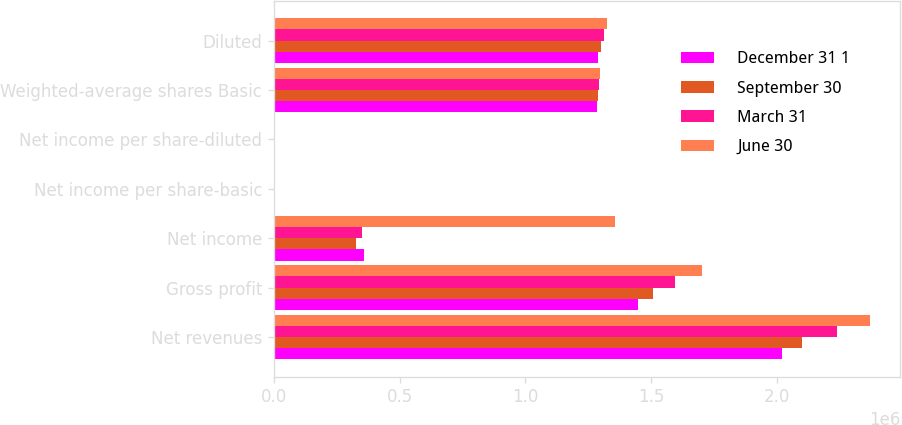Convert chart. <chart><loc_0><loc_0><loc_500><loc_500><stacked_bar_chart><ecel><fcel>Net revenues<fcel>Gross profit<fcel>Net income<fcel>Net income per share-basic<fcel>Net income per share-diluted<fcel>Weighted-average shares Basic<fcel>Diluted<nl><fcel>December 31 1<fcel>2.02059e+06<fcel>1.4472e+06<fcel>357113<fcel>0.28<fcel>0.28<fcel>1.28381e+06<fcel>1.28781e+06<nl><fcel>September 30<fcel>2.09799e+06<fcel>1.50622e+06<fcel>327342<fcel>0.25<fcel>0.25<fcel>1.28882e+06<fcel>1.30043e+06<nl><fcel>March 31<fcel>2.23785e+06<fcel>1.59394e+06<fcel>349736<fcel>0.27<fcel>0.27<fcel>1.29351e+06<fcel>1.31127e+06<nl><fcel>June 30<fcel>2.37093e+06<fcel>1.70024e+06<fcel>1.35491e+06<fcel>1.05<fcel>1.02<fcel>1.29554e+06<fcel>1.32269e+06<nl></chart> 